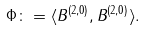<formula> <loc_0><loc_0><loc_500><loc_500>\Phi \colon = \langle B ^ { ( 2 , 0 ) } , B ^ { ( 2 , 0 ) } \rangle .</formula> 